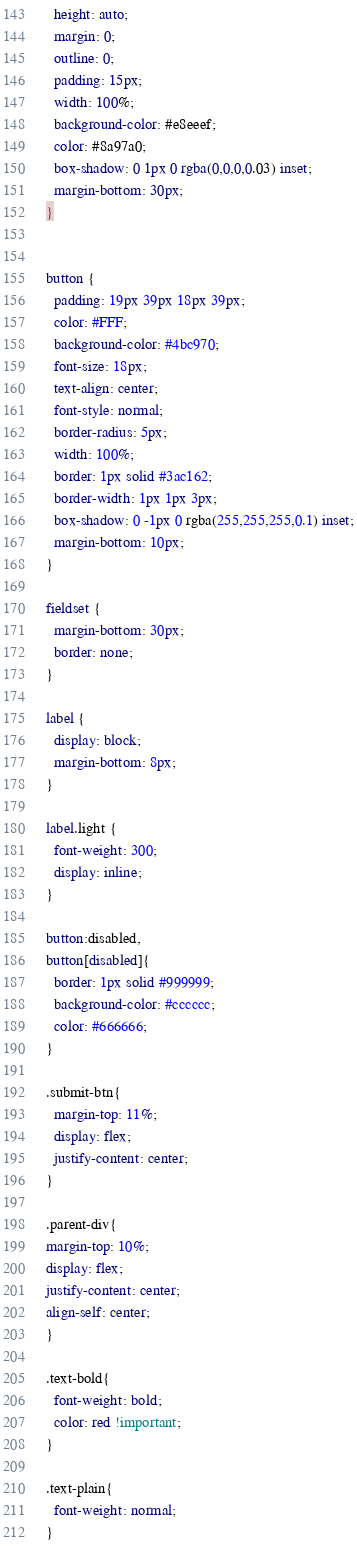<code> <loc_0><loc_0><loc_500><loc_500><_CSS_>  height: auto;
  margin: 0;
  outline: 0;
  padding: 15px;
  width: 100%;
  background-color: #e8eeef;
  color: #8a97a0;
  box-shadow: 0 1px 0 rgba(0,0,0,0.03) inset;
  margin-bottom: 30px;
}


button {
  padding: 19px 39px 18px 39px;
  color: #FFF;
  background-color: #4bc970;
  font-size: 18px;
  text-align: center;
  font-style: normal;
  border-radius: 5px;
  width: 100%;
  border: 1px solid #3ac162;
  border-width: 1px 1px 3px;
  box-shadow: 0 -1px 0 rgba(255,255,255,0.1) inset;
  margin-bottom: 10px;
}

fieldset {
  margin-bottom: 30px;
  border: none;
}

label {
  display: block;
  margin-bottom: 8px;
}

label.light {
  font-weight: 300;
  display: inline;
}

button:disabled,
button[disabled]{
  border: 1px solid #999999;
  background-color: #cccccc;
  color: #666666;
}

.submit-btn{
  margin-top: 11%;
  display: flex;
  justify-content: center;
}

.parent-div{
margin-top: 10%;
display: flex;
justify-content: center;
align-self: center;
}

.text-bold{
  font-weight: bold;
  color: red !important;
}

.text-plain{
  font-weight: normal;
}
</code> 